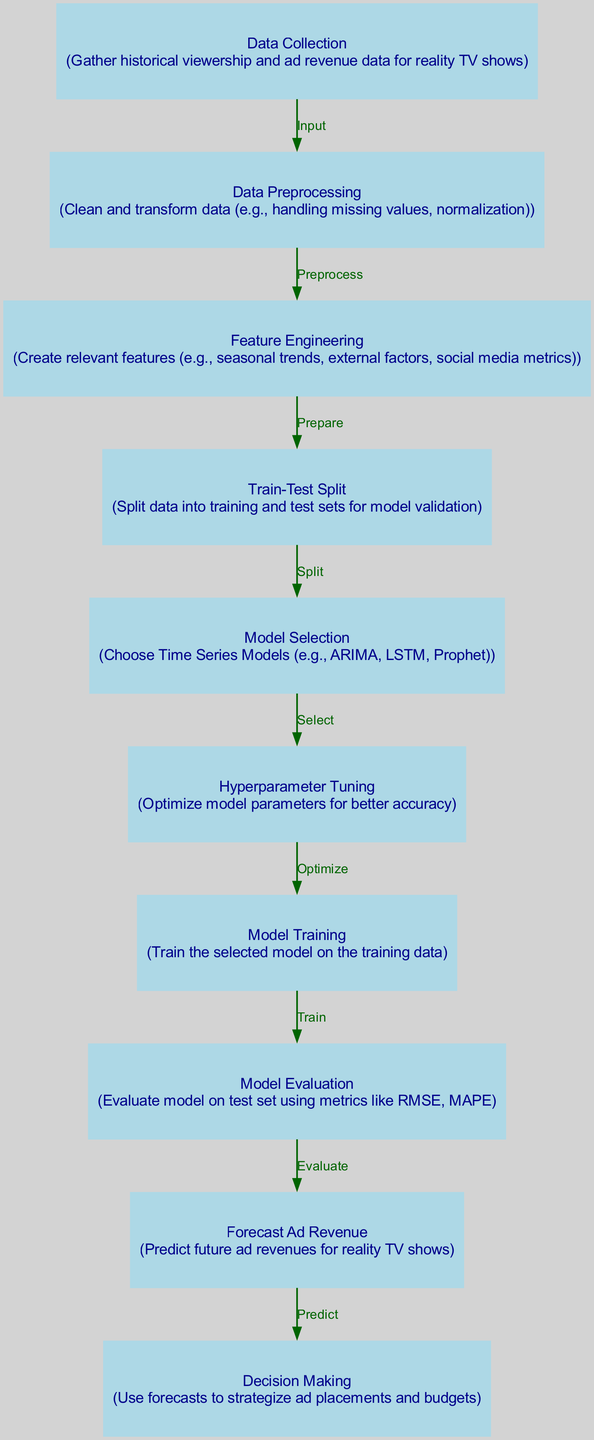What is the first step in the diagram? The first step in the diagram is "Data Collection," where historical viewership and ad revenue data for reality TV shows are gathered.
Answer: Data Collection How many nodes are present in the diagram? There are ten nodes present in the diagram, each representing a distinct step in the process of forecasting ad revenue declines in reality TV using time series analysis.
Answer: Ten What follows the "Model Training" step? After the "Model Training" step, the next step is "Model Evaluation," where the model is evaluated on the test set using various metrics.
Answer: Model Evaluation What kind of models are selected in the "Model Selection" step? In the "Model Selection," time series models such as ARIMA, LSTM, and Prophet are selected for analyzing the data.
Answer: Time Series Models Which process occurs after "Data Preprocessing"? After "Data Preprocessing," the next process is "Feature Engineering," where relevant features are created, like seasonal trends and social media metrics.
Answer: Feature Engineering How does one move from "Train-Test Split" to "Model Selection"? Moving from "Train-Test Split" to "Model Selection" involves taking the split data and selecting appropriate models based on the characteristics of the data.
Answer: Select Models What is the end goal of forecasting in this diagram? The end goal of forecasting is to predict future ad revenues for reality TV shows, based on the insights gained through the preceding steps.
Answer: Predict Future Ad Revenues What is used to strategize ad placements? The forecasts obtained from the "Forecast Ad Revenue" step are used to strategize ad placements and budgets, guiding advertising decisions.
Answer: Forecasts Which process requires optimization for better accuracy? The process that requires optimization for better accuracy is "Hyperparameter Tuning," where model parameters are fine-tuned to improve the model's performance.
Answer: Hyperparameter Tuning 